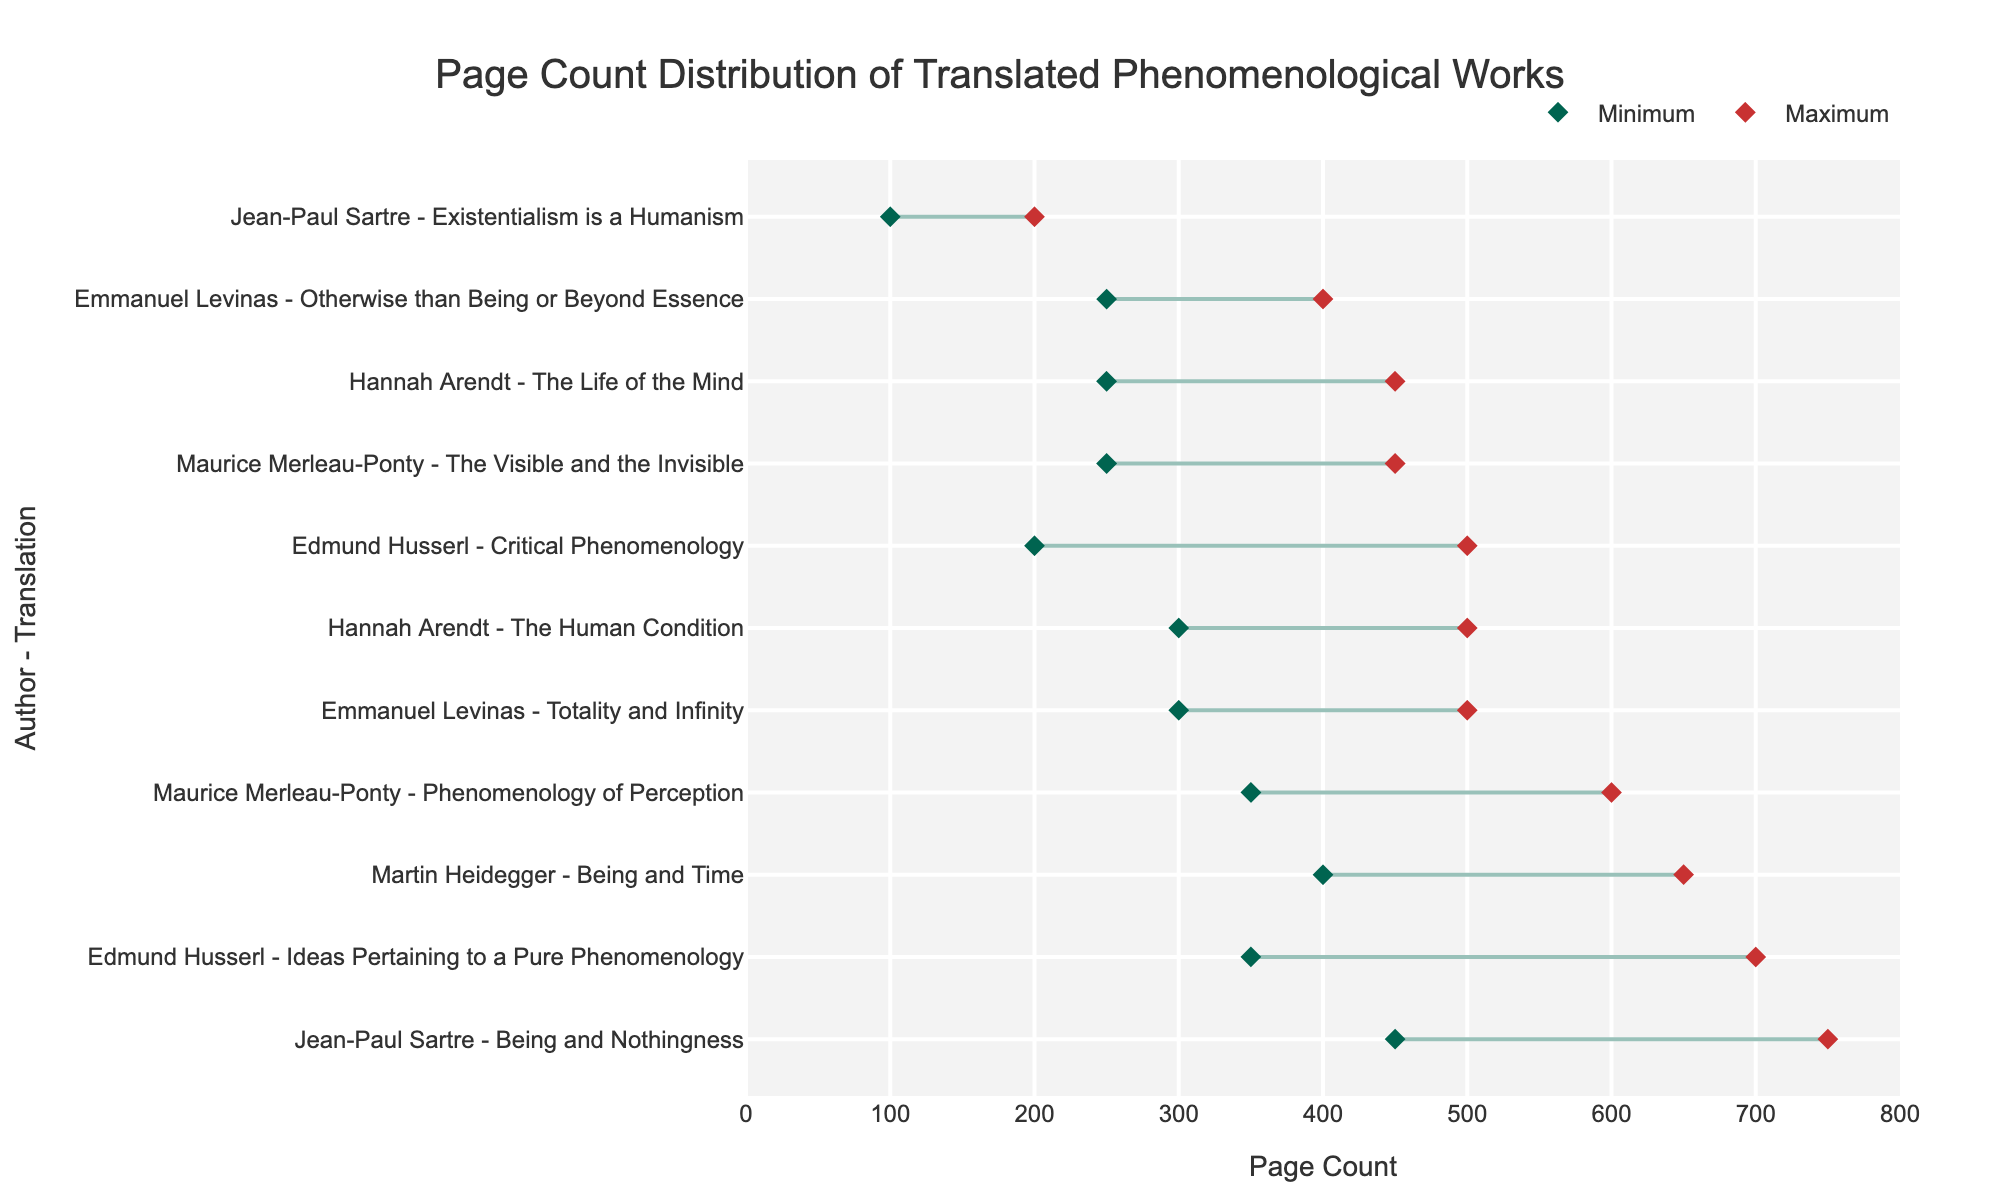What is the range of page counts for Heidegger's "Being and Time"? Refer to the line representing "Being and Time" by Martin Heidegger in the plot. The minimum page count is 400 and the maximum is 650.
Answer: 400 to 650 Which translated work has the highest maximum page count? Compare the maximum page counts of each translation represented by the red markers. Jean-Paul Sartre's "Being and Nothingness" has the highest maximum page count of 750.
Answer: Being and Nothingness How does the range of page counts for Merleau-Ponty's "Phenomenology of Perception" compare to Sartre's "Existentialism is a Humanism"? Look at the lines for both works. "Phenomenology of Perception" ranges from 350 to 600, while "Existentialism is a Humanism" ranges from 100 to 200. Merleau-Ponty's work has both a higher minimum and maximum page count compared to Sartre's.
Answer: Higher Which author's work has the smallest range in page counts? Analyze the lengths of the lines for each author. Sartre's "Existentialism is a Humanism" has the smallest range of 100 to 200 pages.
Answer: Jean-Paul Sartre What is the average page count range for Husserl's translations? Calculate the range for both of Husserl's works and then find the average. "Critical Phenomenology" ranges from 200 to 500 (300 pages) and "Ideas Pertaining to a Pure Phenomenology" ranges from 350 to 700 (350 pages). The average range is (300 + 350) / 2 = 325 pages.
Answer: 325 Which translated work by Hannah Arendt has a larger page count range, "The Human Condition" or "The Life of the Mind"? Compare the range of pages for both works. "The Human Condition" ranges from 300 to 500 (a range of 200 pages) while "The Life of the Mind" ranges from 250 to 450 (a range of 200 pages). Both have equal ranges.
Answer: Equal What is the minimum page count across all translations? Identify the lowest point among the green markers, which represents minimum page counts for each work. The lowest page count is 100, found in Sartre's "Existentialism is a Humanism".
Answer: 100 pages Which author has the most variation in page count among their translated works? Calculate the range for each work of the authors and compare. Sartre's variations are 100 pages for "Existentialism is a Humanism" and 300 pages for "Being and Nothingness" — a total variation of 400 pages. The largest among the given authors.
Answer: Jean-Paul Sartre 